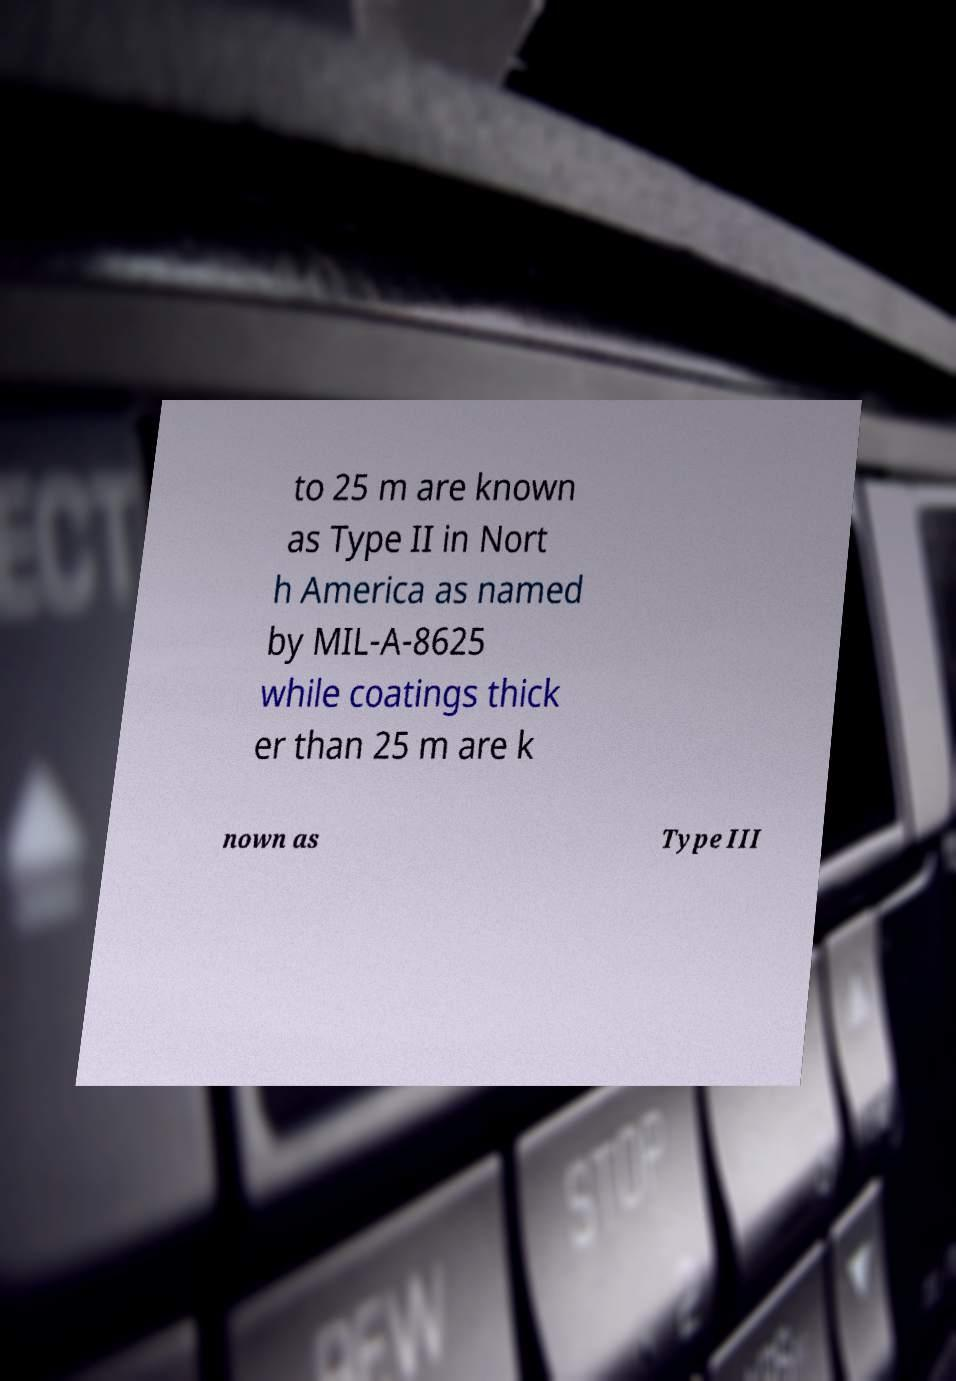Please read and relay the text visible in this image. What does it say? to 25 m are known as Type II in Nort h America as named by MIL-A-8625 while coatings thick er than 25 m are k nown as Type III 